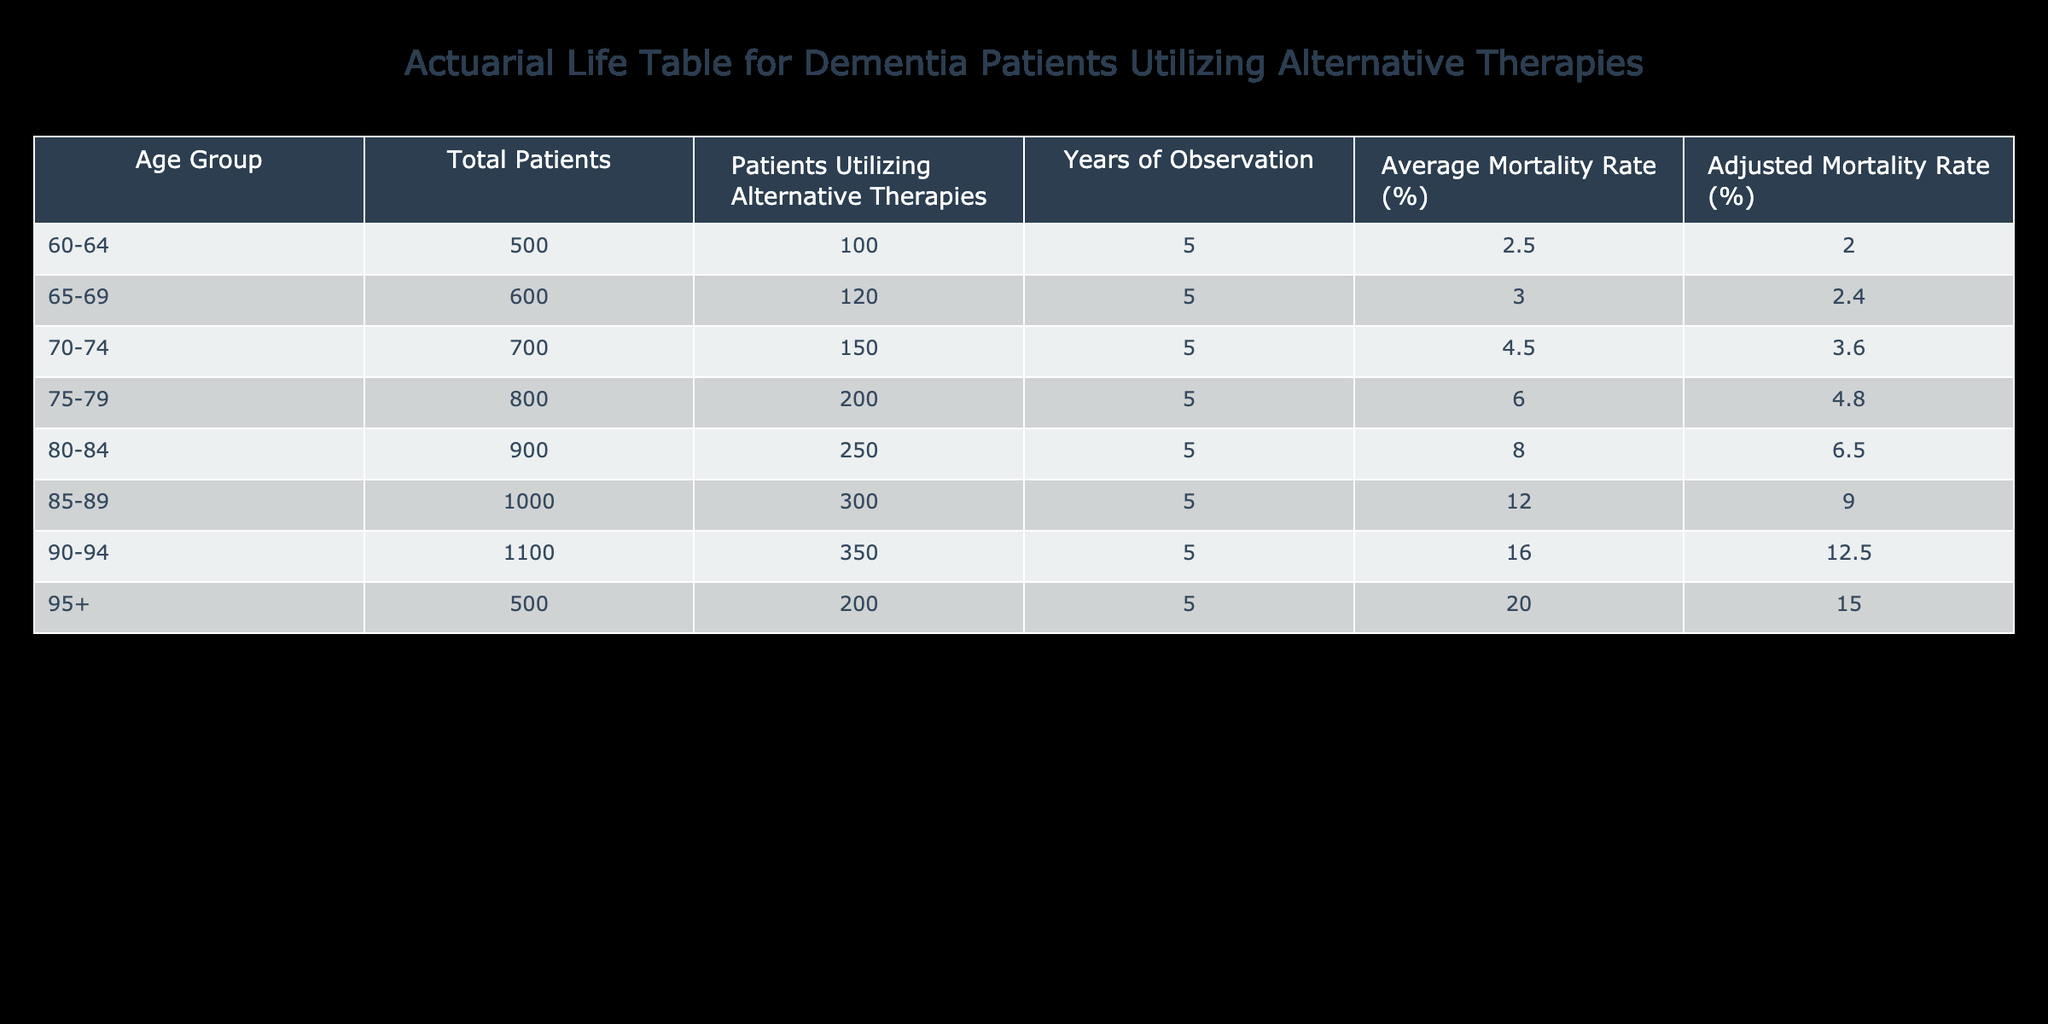What is the average mortality rate for patients aged 60-64 utilizing alternative therapies? From the table, under the age group 60-64, the average mortality rate listed is 2.5%.
Answer: 2.5% How many patients aged 80-84 are utilizing alternative therapies? In the table, it shows that there are 250 patients aged 80-84 utilizing alternative therapies.
Answer: 250 What is the total number of patients across all age groups utilizing alternative therapies? By adding the number of patients utilizing alternative therapies from all age groups: 100 + 120 + 150 + 200 + 250 + 300 + 350 + 200 = 1,770.
Answer: 1770 Are patients aged 90-94 utilizing alternative therapies at a higher adjusted mortality rate than those aged 85-89? The adjusted mortality rate for patients aged 90-94 is 12.5%, while for those aged 85-89, it is 9.0%. Therefore, yes, patients aged 90-94 have a higher adjusted mortality rate.
Answer: Yes What is the difference in average mortality rate between the age groups 70-74 and 75-79? The average mortality rate for patients aged 70-74 is 4.5%, while for those aged 75-79, it is 6.0%. The difference is 6.0% - 4.5% = 1.5%.
Answer: 1.5% Which age group has the highest adjusted mortality rate for patients utilizing alternative therapies? Looking at the adjusted mortality rates, the age group 95+ has the highest rate at 15.0%.
Answer: 95+ What percentage of patients aged 65-69 are utilizing alternative therapies? In the age group of 65-69, there are 120 patients utilizing alternative therapies out of a total of 600 patients. Therefore, the percentage is (120/600) * 100 = 20%.
Answer: 20% Is the average mortality rate for the age group 80-84 less than 10%? The average mortality rate for patients aged 80-84 is 8.0%, which is less than 10%. Therefore, the answer is yes.
Answer: Yes How does the total number of patients aged 75-79 compare to those aged 85-89? For age group 75-79, there are 800 patients, while for age group 85-89, there are 1000 patients. Thus, 800 is less than 1000.
Answer: 800 is less than 1000 